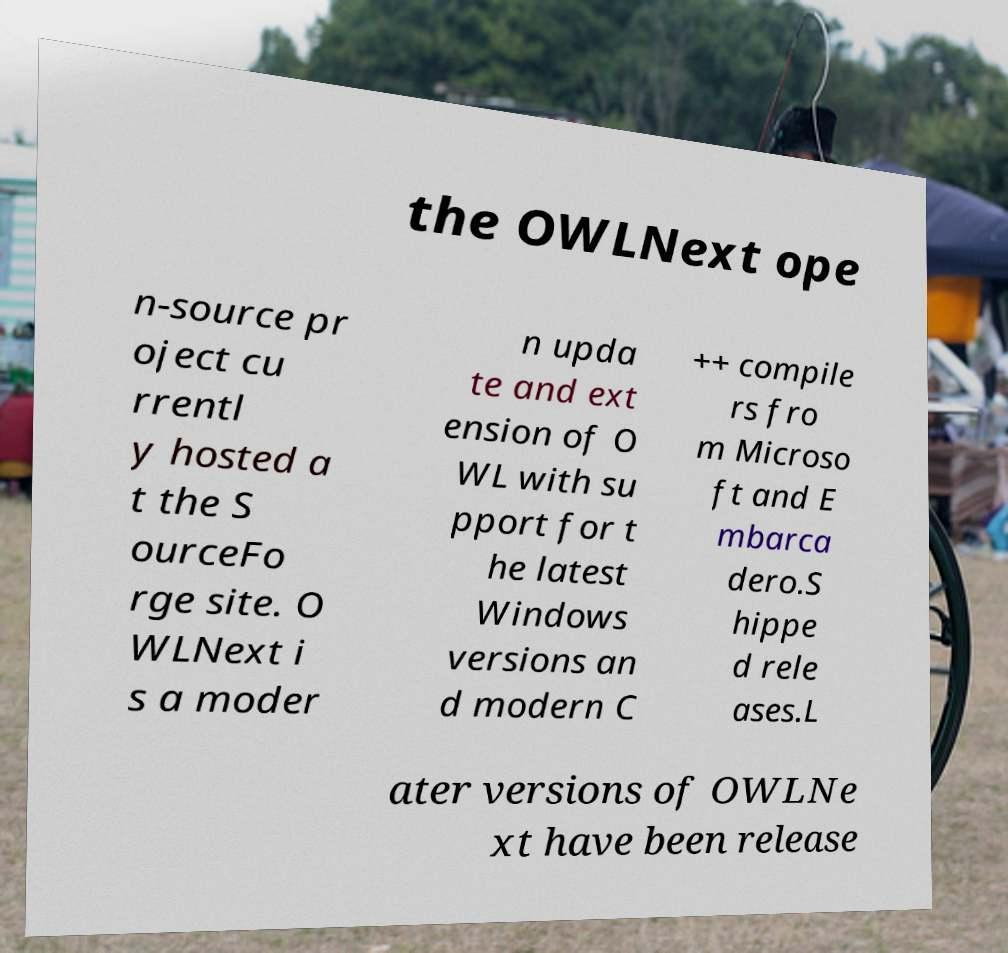Please identify and transcribe the text found in this image. the OWLNext ope n-source pr oject cu rrentl y hosted a t the S ourceFo rge site. O WLNext i s a moder n upda te and ext ension of O WL with su pport for t he latest Windows versions an d modern C ++ compile rs fro m Microso ft and E mbarca dero.S hippe d rele ases.L ater versions of OWLNe xt have been release 